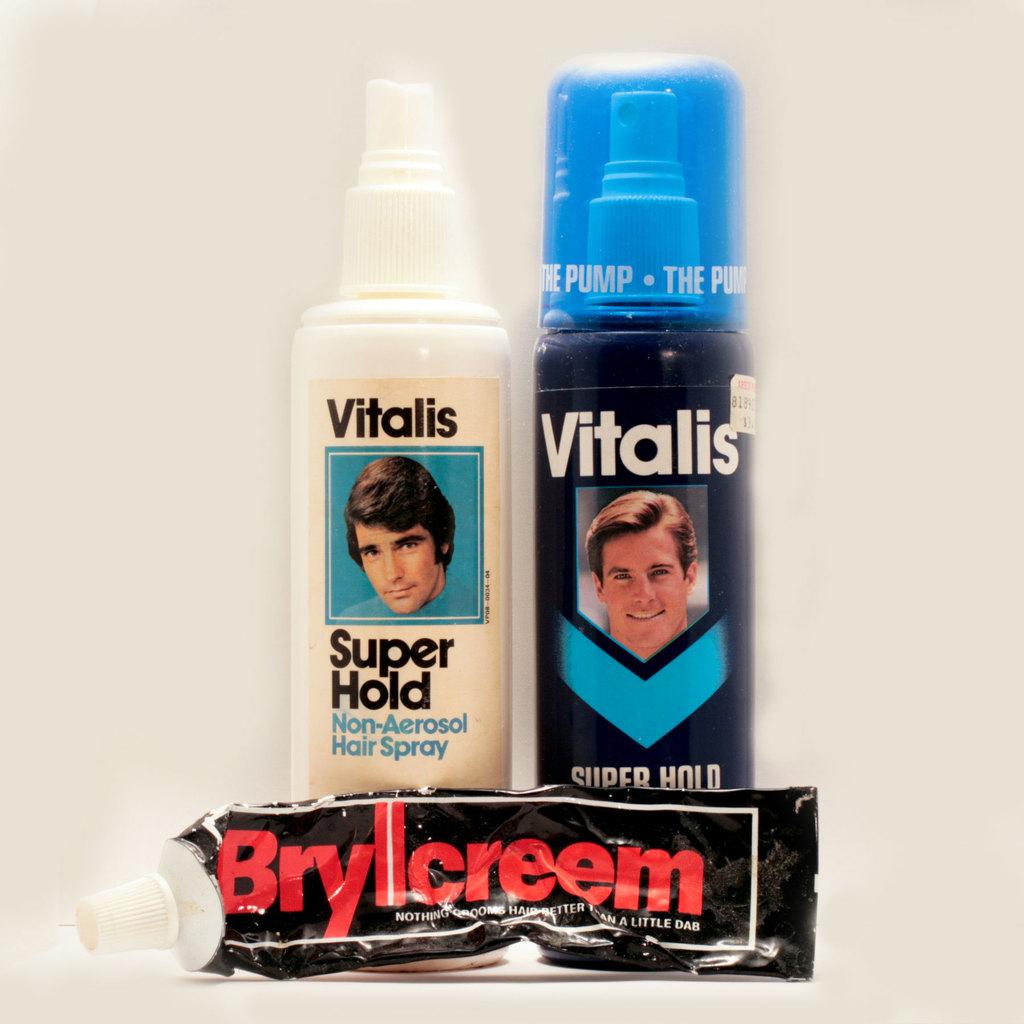What is the first bottle used for?
Ensure brevity in your answer.  Hair spray. 